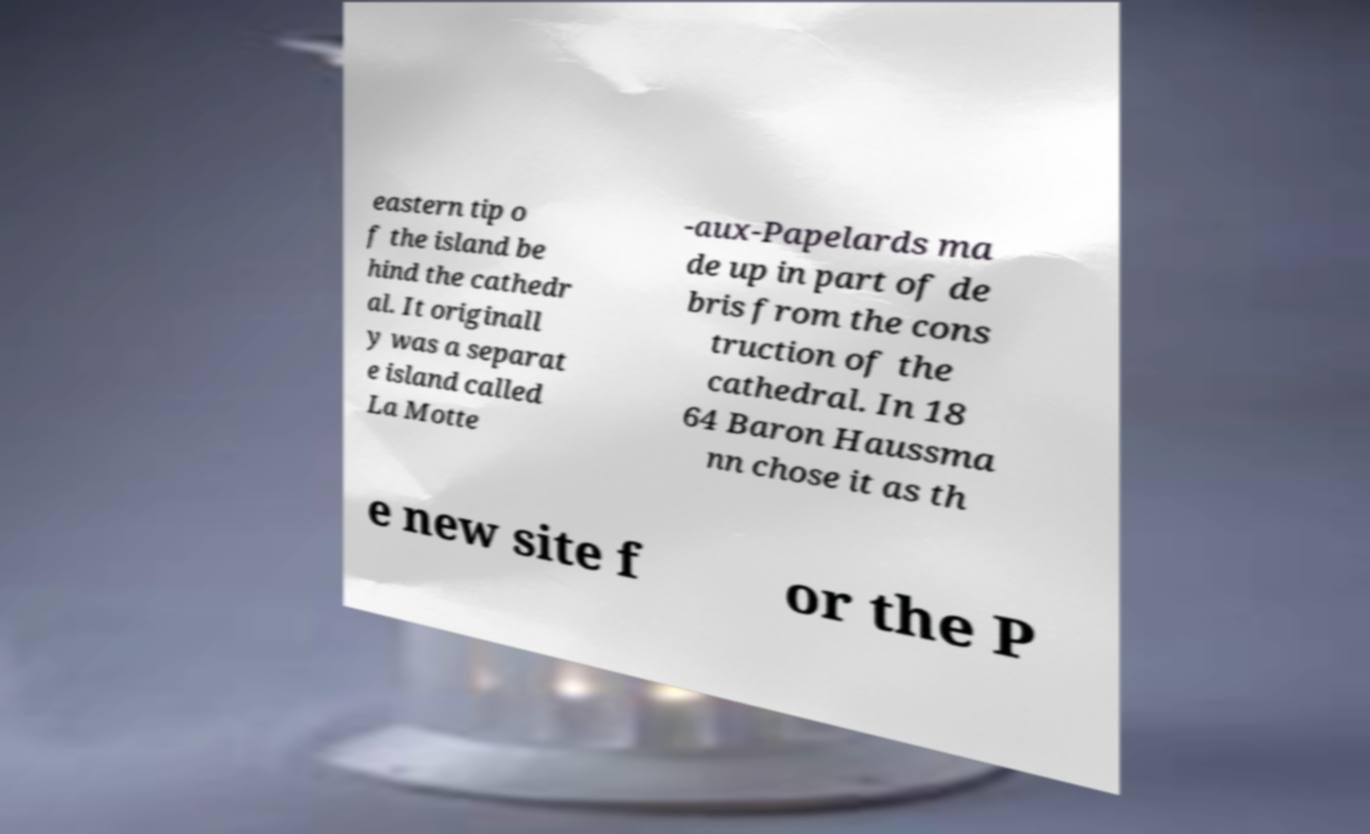Please read and relay the text visible in this image. What does it say? eastern tip o f the island be hind the cathedr al. It originall y was a separat e island called La Motte -aux-Papelards ma de up in part of de bris from the cons truction of the cathedral. In 18 64 Baron Haussma nn chose it as th e new site f or the P 